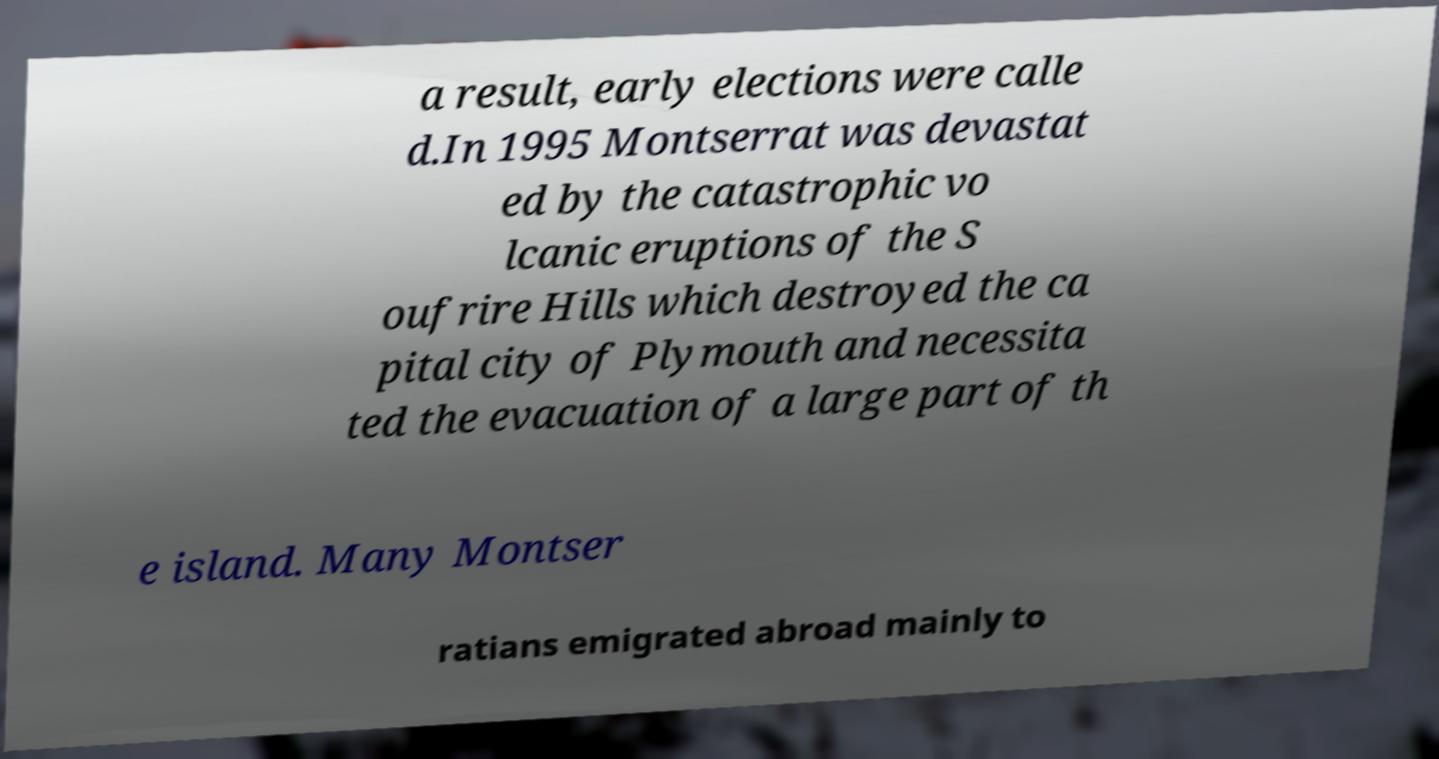I need the written content from this picture converted into text. Can you do that? a result, early elections were calle d.In 1995 Montserrat was devastat ed by the catastrophic vo lcanic eruptions of the S oufrire Hills which destroyed the ca pital city of Plymouth and necessita ted the evacuation of a large part of th e island. Many Montser ratians emigrated abroad mainly to 